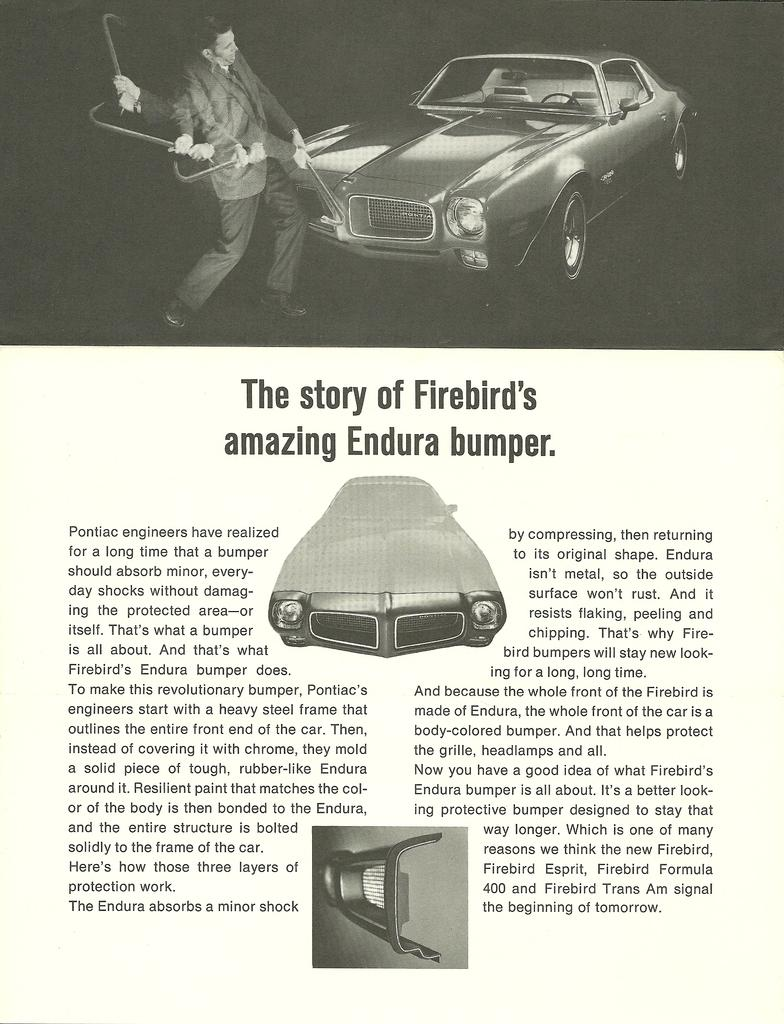What is the main subject of the image? There is a person depicted in the image. What else can be seen in the image besides the person? There is a car in the image. Is there any text present in the image? Yes, there is some text in the image. What type of smoke is coming out of the person's brain in the image? There is no smoke or brain depicted in the image; it only features a person, a car, and some text. 